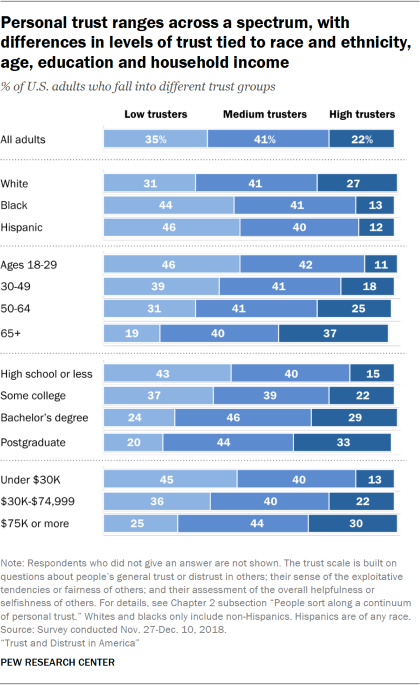Highlight a few significant elements in this photo. The navy blue bar represents a high level of trust. 